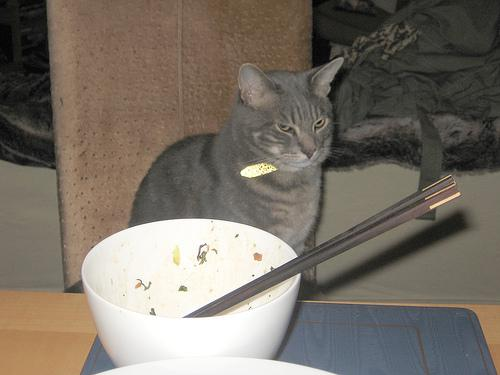Question: what color is the cat?
Choices:
A. Brown.
B. Grey.
C. Black.
D. White.
Answer with the letter. Answer: B Question: what are the long objects in the bowl?
Choices:
A. Forks.
B. Knives.
C. Spoons.
D. Chopsticks.
Answer with the letter. Answer: D Question: how many cats are there?
Choices:
A. 2.
B. 3.
C. 4.
D. 1.
Answer with the letter. Answer: D Question: what color are the cat's eyes?
Choices:
A. Red.
B. Black.
C. Yellow.
D. Blue.
Answer with the letter. Answer: C Question: where is the cat?
Choices:
A. On the table.
B. Sleeping.
C. In bed.
D. At the door.
Answer with the letter. Answer: A Question: how many people are in the picture?
Choices:
A. 1.
B. 0.
C. 2.
D. 3.
Answer with the letter. Answer: B Question: where is the bowl?
Choices:
A. On the floor.
B. On a chair.
C. On a plate.
D. On a table.
Answer with the letter. Answer: D 